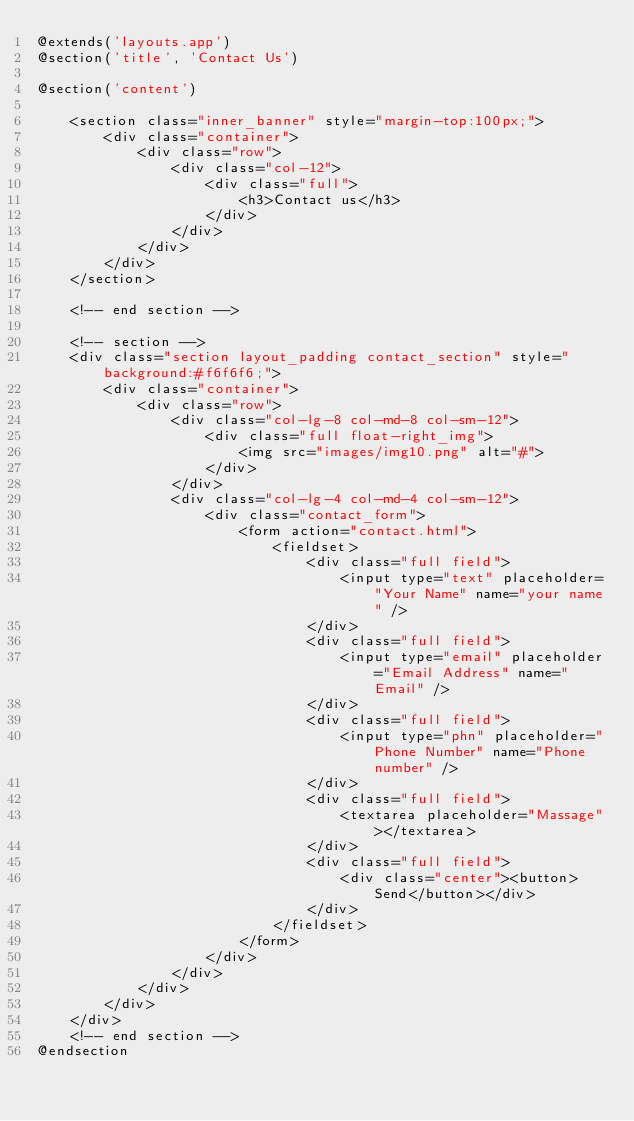Convert code to text. <code><loc_0><loc_0><loc_500><loc_500><_PHP_>@extends('layouts.app')
@section('title', 'Contact Us')

@section('content')

    <section class="inner_banner" style="margin-top:100px;">
        <div class="container">
            <div class="row">
                <div class="col-12">
                    <div class="full">
                        <h3>Contact us</h3>
                    </div>
                </div>
            </div>
        </div>
    </section>

    <!-- end section -->

    <!-- section -->
    <div class="section layout_padding contact_section" style="background:#f6f6f6;">
        <div class="container">
            <div class="row">
                <div class="col-lg-8 col-md-8 col-sm-12">
                    <div class="full float-right_img">
                        <img src="images/img10.png" alt="#">
                    </div>
                </div>
                <div class="col-lg-4 col-md-4 col-sm-12">
                    <div class="contact_form">
                        <form action="contact.html">
                            <fieldset>
                                <div class="full field">
                                    <input type="text" placeholder="Your Name" name="your name" />
                                </div>
                                <div class="full field">
                                    <input type="email" placeholder="Email Address" name="Email" />
                                </div>
                                <div class="full field">
                                    <input type="phn" placeholder="Phone Number" name="Phone number" />
                                </div>
                                <div class="full field">
                                    <textarea placeholder="Massage"></textarea>
                                </div>
                                <div class="full field">
                                    <div class="center"><button>Send</button></div>
                                </div>
                            </fieldset>
                        </form>
                    </div>
                </div>
            </div>
        </div>
    </div>
    <!-- end section -->
@endsection
</code> 